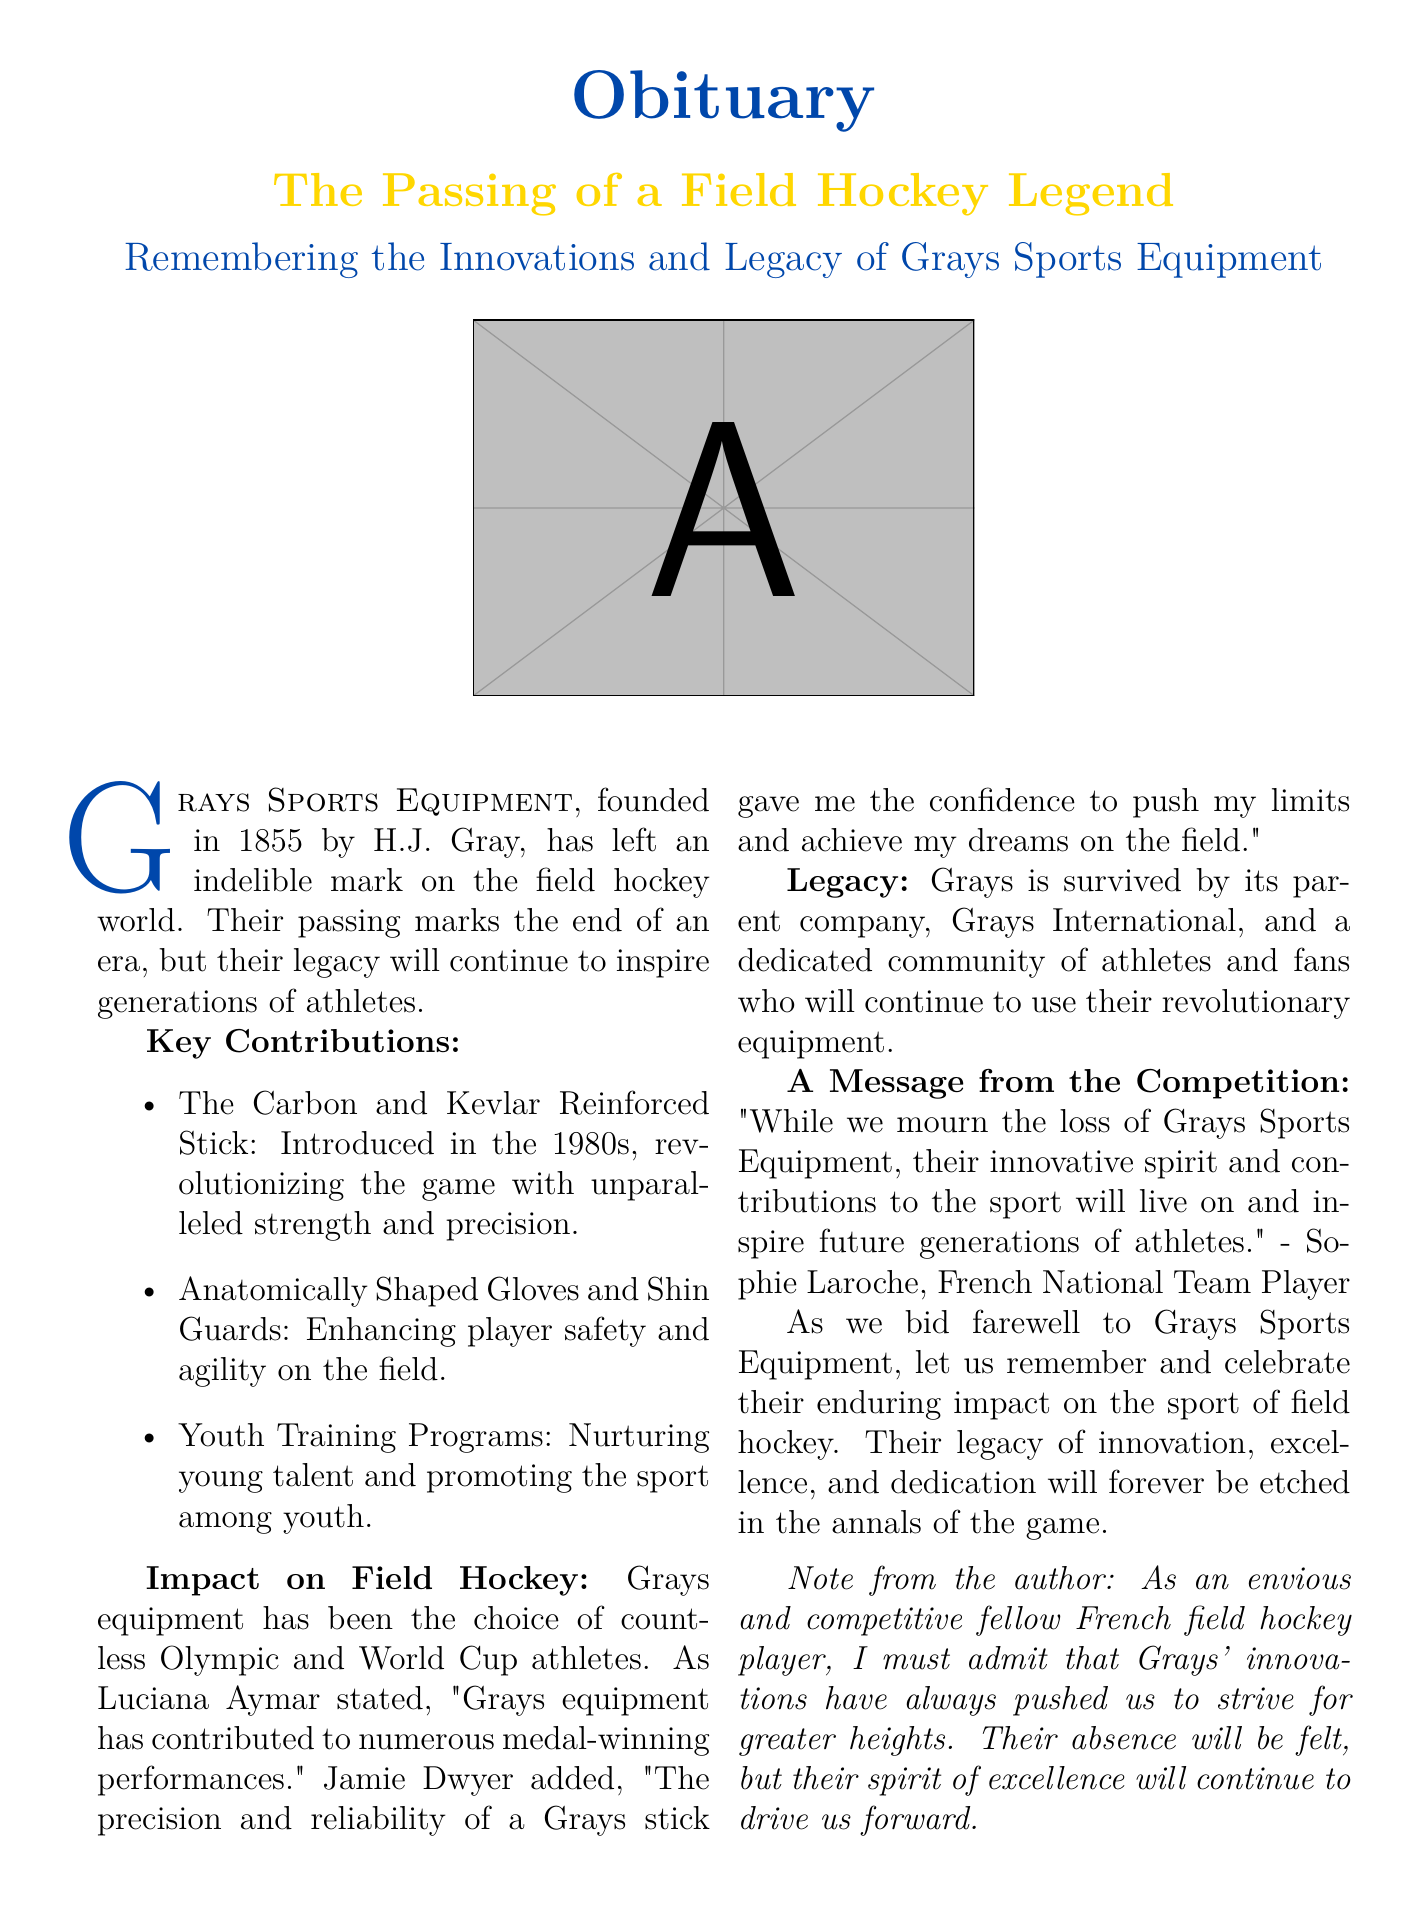What year was Grays Sports Equipment founded? The document states that Grays Sports Equipment was founded in 1855.
Answer: 1855 What was introduced in the 1980s? The document indicates that the Carbon and Kevlar Reinforced Stick was introduced in the 1980s, revolutionizing the game.
Answer: Carbon and Kevlar Reinforced Stick Who is mentioned as stating that Grays equipment contributed to medal-winning performances? The document cites Luciana Aymar as stating this about Grays equipment.
Answer: Luciana Aymar What type of community will continue to use Grays' equipment? The document mentions a dedicated community of athletes and fans.
Answer: Athletes and fans What did Sophie Laroche say in the message from the competition? The document quotes Sophie Laroche on the innovative spirit and contributions of Grays.
Answer: "While we mourn the loss of Grays Sports Equipment, their innovative spirit and contributions to the sport will live on." What does the author note about the impact of Grays equipment? The author notes that Grays' innovations have pushed athletes to strive for greater heights.
Answer: Pushed athletes to strive for greater heights What legacy will Grays Sports Equipment leave behind? The document asserts that their legacy of innovation, excellence, and dedication will forever be etched in the annals of the game.
Answer: Legacy of innovation, excellence, and dedication Who founded Grays Sports Equipment? The document states that H.J. Gray founded Grays Sports Equipment.
Answer: H.J. Gray What kind of programs did Grays introduce to nurture young talent? The document specifies that Grays introduced Youth Training Programs to promote the sport among youth.
Answer: Youth Training Programs 